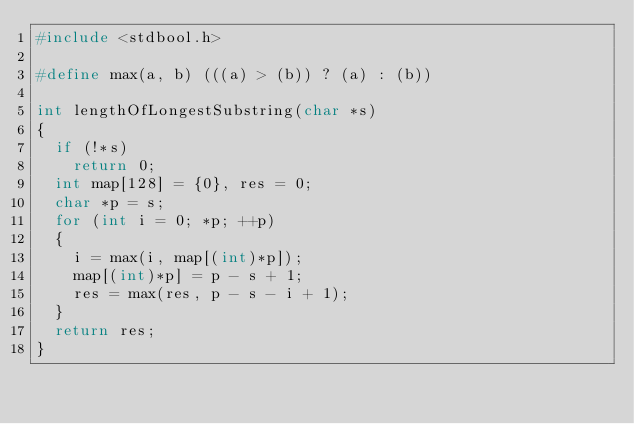Convert code to text. <code><loc_0><loc_0><loc_500><loc_500><_C_>#include <stdbool.h>

#define max(a, b) (((a) > (b)) ? (a) : (b))

int lengthOfLongestSubstring(char *s)
{
	if (!*s)
		return 0;
	int map[128] = {0}, res = 0;
	char *p = s;
	for (int i = 0; *p; ++p)
	{
		i = max(i, map[(int)*p]);
		map[(int)*p] = p - s + 1;
		res = max(res, p - s - i + 1);
	}
	return res;
}</code> 